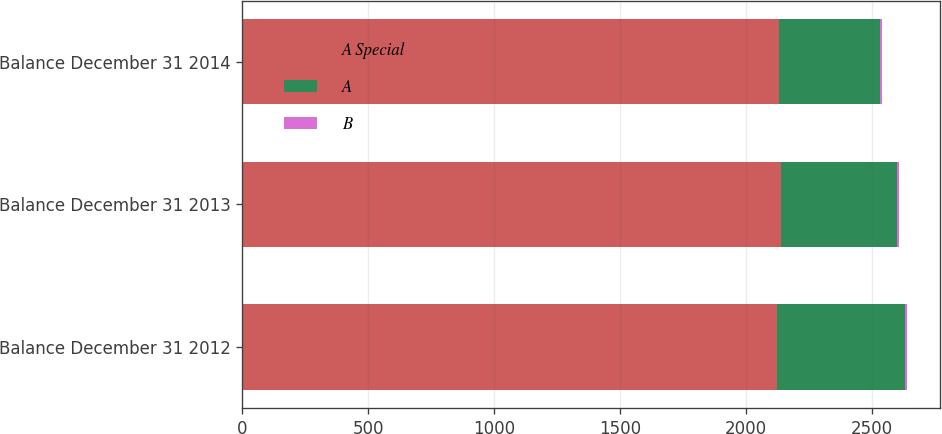<chart> <loc_0><loc_0><loc_500><loc_500><stacked_bar_chart><ecel><fcel>Balance December 31 2012<fcel>Balance December 31 2013<fcel>Balance December 31 2014<nl><fcel>A Special<fcel>2122<fcel>2138<fcel>2131<nl><fcel>A<fcel>508<fcel>459<fcel>400<nl><fcel>B<fcel>9<fcel>9<fcel>9<nl></chart> 